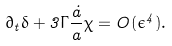Convert formula to latex. <formula><loc_0><loc_0><loc_500><loc_500>\partial _ { t } { \delta } + 3 \Gamma \frac { \dot { a } } { a } \chi = O ( \epsilon ^ { 4 } ) .</formula> 